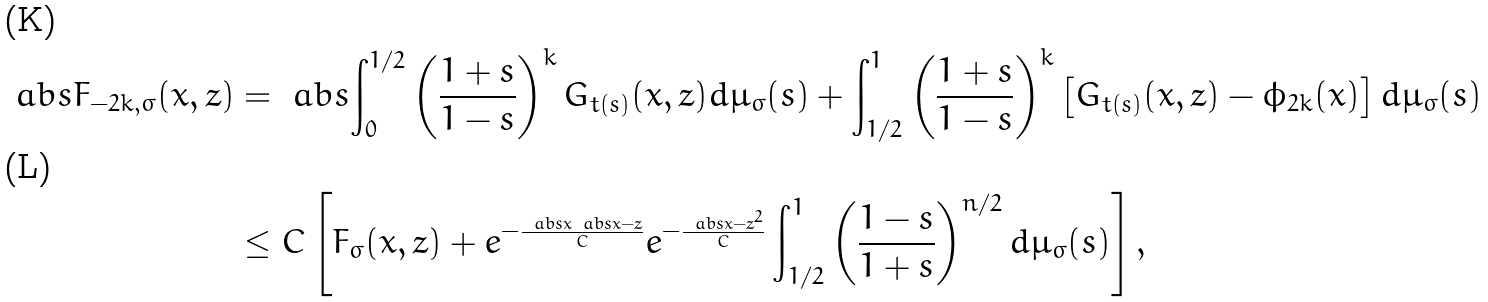Convert formula to latex. <formula><loc_0><loc_0><loc_500><loc_500>\ a b s { F _ { - 2 k , \sigma } ( x , z ) } & = \ a b s { \int _ { 0 } ^ { 1 / 2 } \left ( \frac { 1 + s } { 1 - s } \right ) ^ { k } G _ { t ( s ) } ( x , z ) d \mu _ { \sigma } ( s ) + \int _ { 1 / 2 } ^ { 1 } \left ( \frac { 1 + s } { 1 - s } \right ) ^ { k } \left [ G _ { t ( s ) } ( x , z ) - \phi _ { 2 k } ( x ) \right ] d \mu _ { \sigma } ( s ) } \\ & \leq C \left [ F _ { \sigma } ( x , z ) + e ^ { - \frac { \ a b s { x } \ a b s { x - z } } { C } } e ^ { - \frac { \ a b s { x - z } ^ { 2 } } { C } } \int _ { 1 / 2 } ^ { 1 } \left ( \frac { 1 - s } { 1 + s } \right ) ^ { n / 2 } d \mu _ { \sigma } ( s ) \right ] ,</formula> 